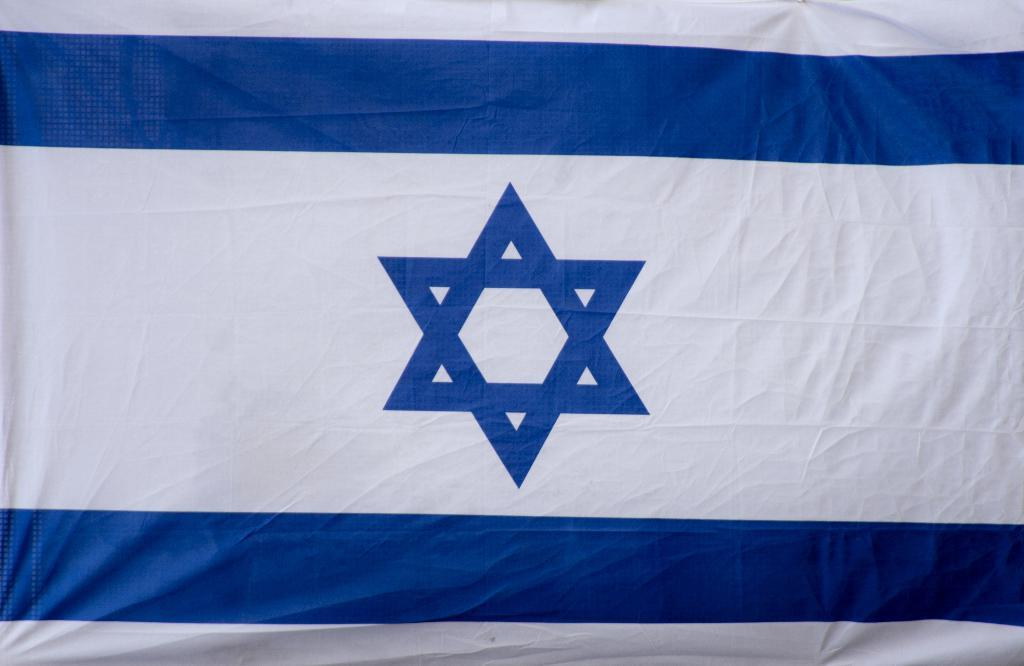What is the main object in the image that has colors? There is a banner or a flag in the image that has white and blue colors. Can you describe the design on the flag? The flag has a star drawn on it in blue color. How many clovers can be seen on the flag in the image? There are no clovers present on the flag in the image; it only has a blue star. What type of metal is used to make the bridge in the image? There is no bridge present in the image; it only features a banner or a flag. 